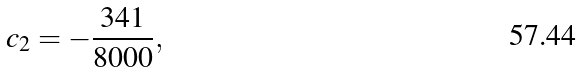<formula> <loc_0><loc_0><loc_500><loc_500>c _ { 2 } = - { \frac { 3 4 1 } { 8 0 0 0 } } ,</formula> 